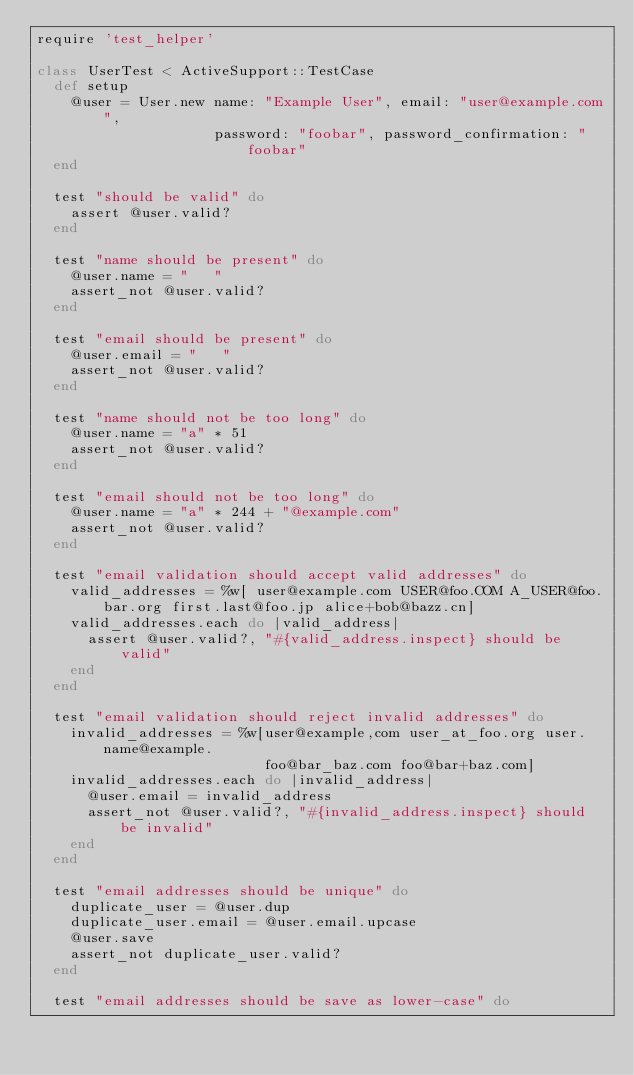<code> <loc_0><loc_0><loc_500><loc_500><_Ruby_>require 'test_helper'

class UserTest < ActiveSupport::TestCase
  def setup
    @user = User.new name: "Example User", email: "user@example.com",
                     password: "foobar", password_confirmation: "foobar"
  end

  test "should be valid" do
    assert @user.valid?
  end

  test "name should be present" do
    @user.name = "   "
    assert_not @user.valid?
  end

  test "email should be present" do
    @user.email = "   "
    assert_not @user.valid?
  end

  test "name should not be too long" do
    @user.name = "a" * 51
    assert_not @user.valid?
  end

  test "email should not be too long" do
    @user.name = "a" * 244 + "@example.com"
    assert_not @user.valid?
  end

  test "email validation should accept valid addresses" do
    valid_addresses = %w[ user@example.com USER@foo.COM A_USER@foo.bar.org first.last@foo.jp alice+bob@bazz.cn]
    valid_addresses.each do |valid_address|
      assert @user.valid?, "#{valid_address.inspect} should be valid"
    end
  end

  test "email validation should reject invalid addresses" do
    invalid_addresses = %w[user@example,com user_at_foo.org user.name@example.
                           foo@bar_baz.com foo@bar+baz.com]
    invalid_addresses.each do |invalid_address|
      @user.email = invalid_address
      assert_not @user.valid?, "#{invalid_address.inspect} should be invalid"
    end
  end

  test "email addresses should be unique" do
    duplicate_user = @user.dup
    duplicate_user.email = @user.email.upcase
    @user.save
    assert_not duplicate_user.valid?
  end

  test "email addresses should be save as lower-case" do</code> 